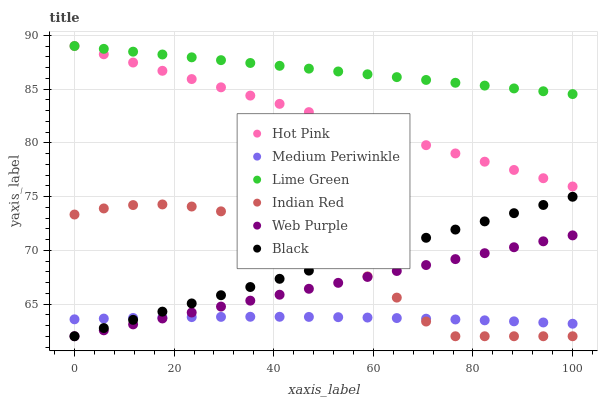Does Medium Periwinkle have the minimum area under the curve?
Answer yes or no. Yes. Does Lime Green have the maximum area under the curve?
Answer yes or no. Yes. Does Web Purple have the minimum area under the curve?
Answer yes or no. No. Does Web Purple have the maximum area under the curve?
Answer yes or no. No. Is Web Purple the smoothest?
Answer yes or no. Yes. Is Indian Red the roughest?
Answer yes or no. Yes. Is Medium Periwinkle the smoothest?
Answer yes or no. No. Is Medium Periwinkle the roughest?
Answer yes or no. No. Does Web Purple have the lowest value?
Answer yes or no. Yes. Does Medium Periwinkle have the lowest value?
Answer yes or no. No. Does Lime Green have the highest value?
Answer yes or no. Yes. Does Web Purple have the highest value?
Answer yes or no. No. Is Web Purple less than Lime Green?
Answer yes or no. Yes. Is Hot Pink greater than Black?
Answer yes or no. Yes. Does Medium Periwinkle intersect Indian Red?
Answer yes or no. Yes. Is Medium Periwinkle less than Indian Red?
Answer yes or no. No. Is Medium Periwinkle greater than Indian Red?
Answer yes or no. No. Does Web Purple intersect Lime Green?
Answer yes or no. No. 